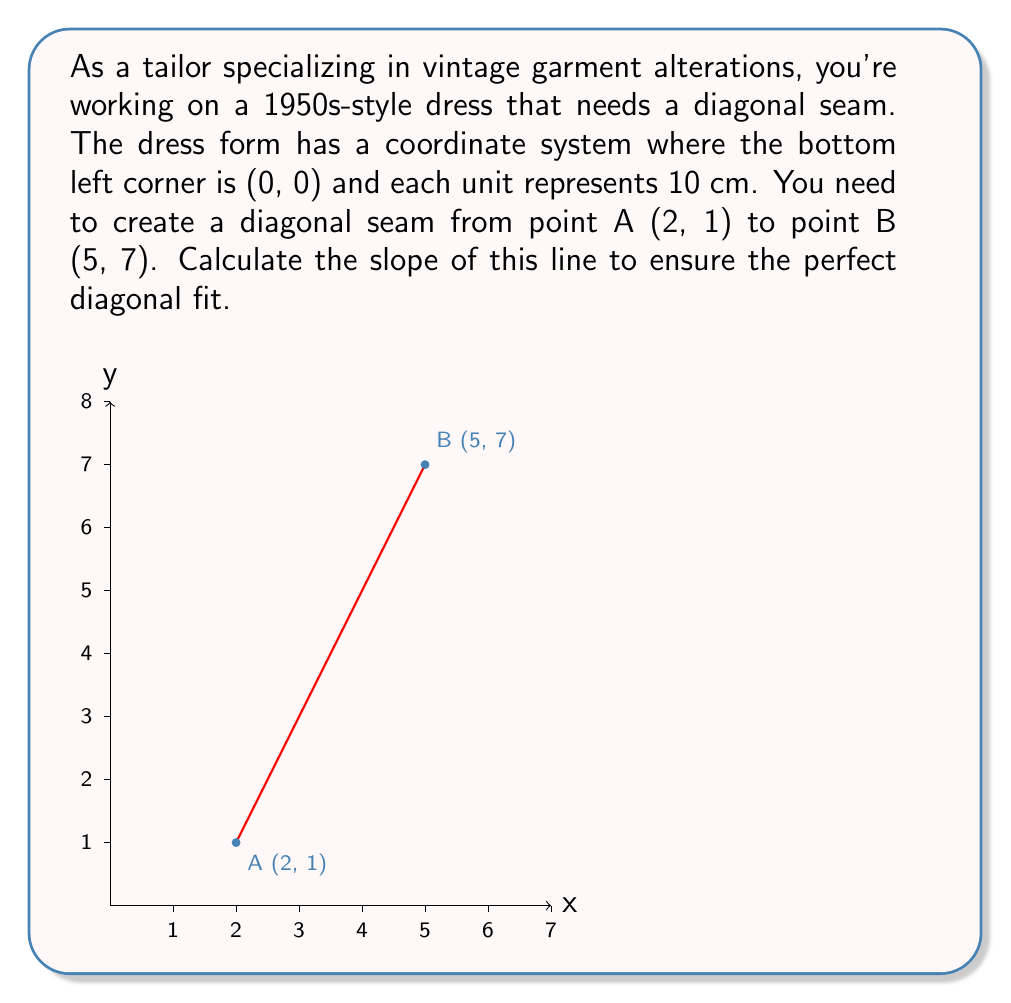Help me with this question. To calculate the slope of the line, we'll use the slope formula:

$$ m = \frac{y_2 - y_1}{x_2 - x_1} $$

Where $(x_1, y_1)$ is the first point and $(x_2, y_2)$ is the second point.

Given:
- Point A: $(x_1, y_1) = (2, 1)$
- Point B: $(x_2, y_2) = (5, 7)$

Let's substitute these values into the formula:

$$ m = \frac{7 - 1}{5 - 2} = \frac{6}{3} $$

Simplifying the fraction:

$$ m = 2 $$

This means that for every 1 unit increase in x, y increases by 2 units. In the context of the dress, for every 10 cm you move horizontally, the seam rises 20 cm vertically.
Answer: $m = 2$ 